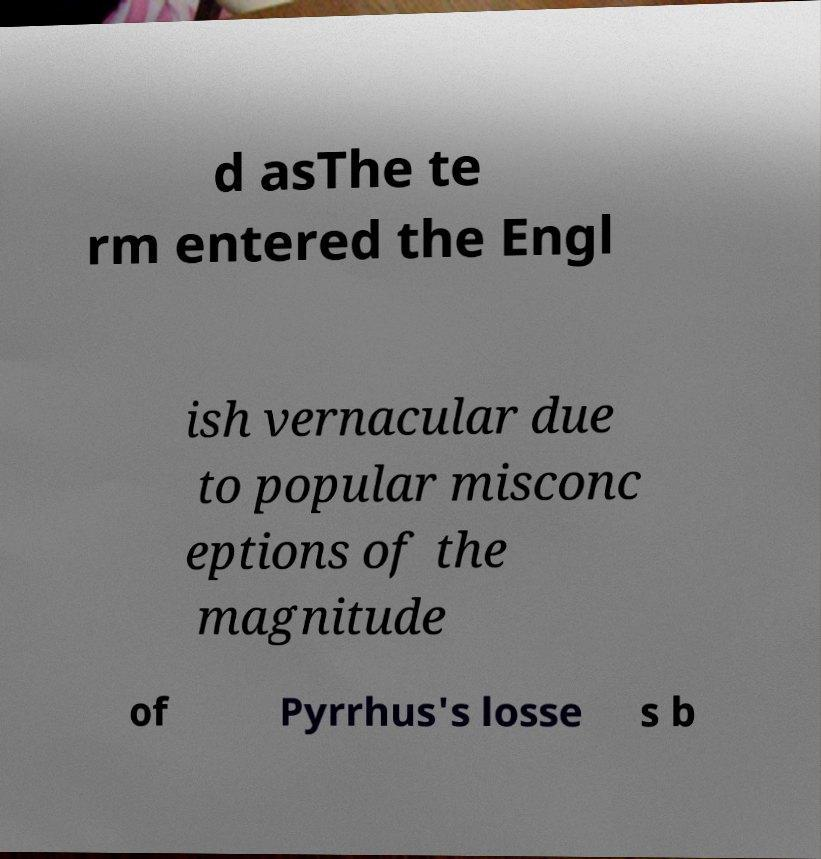Could you assist in decoding the text presented in this image and type it out clearly? d asThe te rm entered the Engl ish vernacular due to popular misconc eptions of the magnitude of Pyrrhus's losse s b 